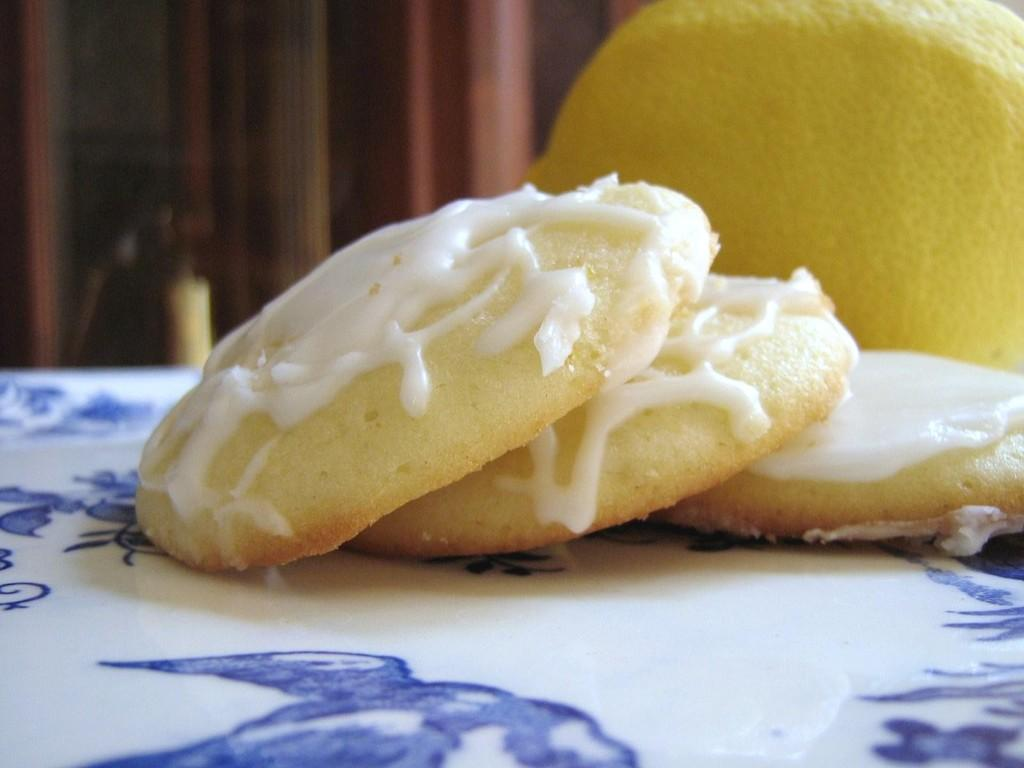What type of cookies are shown in the image? There are cookies with cream in the image. How are the cookies arranged or displayed? The cookies are on a plate. What other food item is visible in the image? There is an orange to the right of the plate. What can be seen in the background of the image? There are brown curtains in the background of the image. How does the nerve affect the cookies in the image? There is no mention of a nerve in the image, and it does not have any effect on the cookies. Can you describe the breath of the cookies in the image? Cookies do not have breath, so this question is not applicable to the image. 